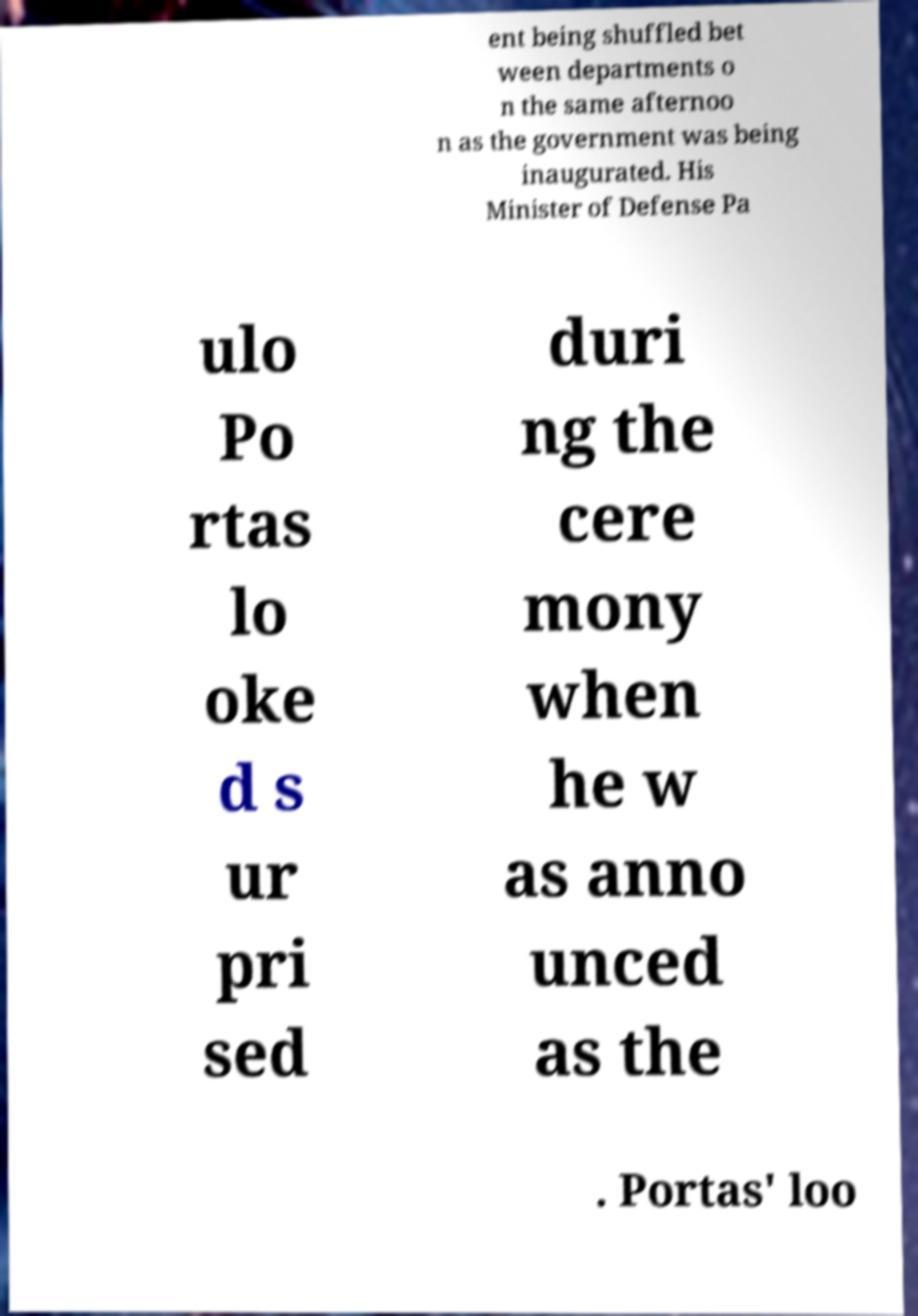There's text embedded in this image that I need extracted. Can you transcribe it verbatim? ent being shuffled bet ween departments o n the same afternoo n as the government was being inaugurated. His Minister of Defense Pa ulo Po rtas lo oke d s ur pri sed duri ng the cere mony when he w as anno unced as the . Portas' loo 